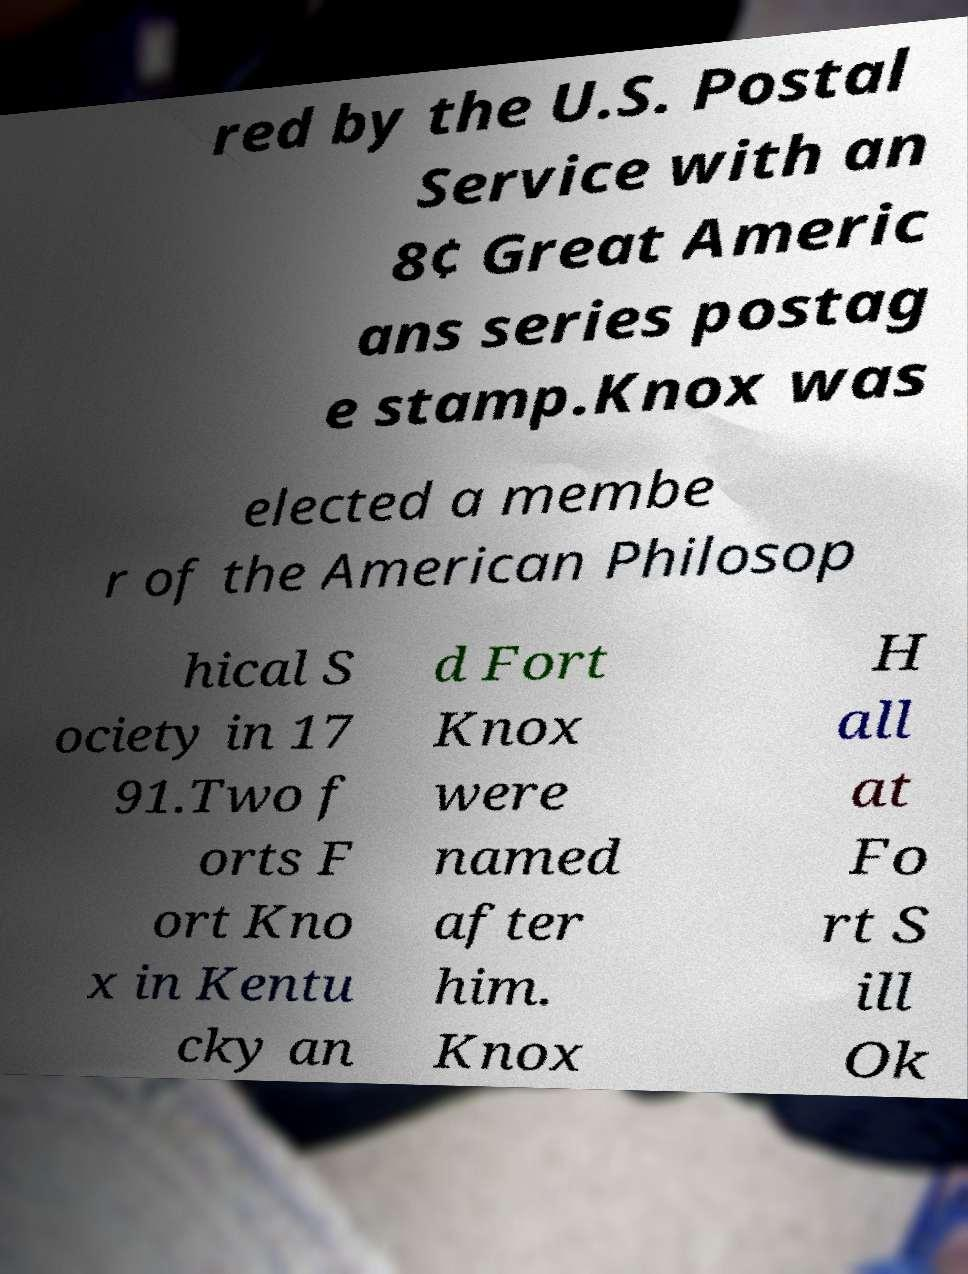Can you accurately transcribe the text from the provided image for me? red by the U.S. Postal Service with an 8¢ Great Americ ans series postag e stamp.Knox was elected a membe r of the American Philosop hical S ociety in 17 91.Two f orts F ort Kno x in Kentu cky an d Fort Knox were named after him. Knox H all at Fo rt S ill Ok 